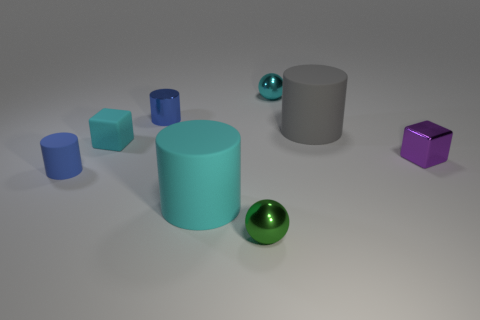There is a green sphere that is the same material as the purple cube; what is its size?
Your answer should be compact. Small. What number of objects are either cyan objects that are to the left of the green ball or tiny metallic objects behind the gray object?
Your answer should be very brief. 4. Are there the same number of matte objects left of the tiny cyan block and big cyan rubber things on the left side of the tiny rubber cylinder?
Your answer should be very brief. No. There is a small cylinder that is in front of the gray cylinder; what is its color?
Provide a succinct answer. Blue. Is the color of the shiny cylinder the same as the cylinder that is to the left of the small cyan cube?
Provide a succinct answer. Yes. Are there fewer big yellow rubber things than large gray rubber things?
Your response must be concise. Yes. There is a big object that is on the left side of the gray cylinder; is its color the same as the rubber block?
Provide a short and direct response. Yes. How many blue shiny things are the same size as the cyan ball?
Offer a very short reply. 1. Is there a large metallic cube of the same color as the small matte cube?
Your response must be concise. No. Are the green thing and the cyan sphere made of the same material?
Your response must be concise. Yes. 